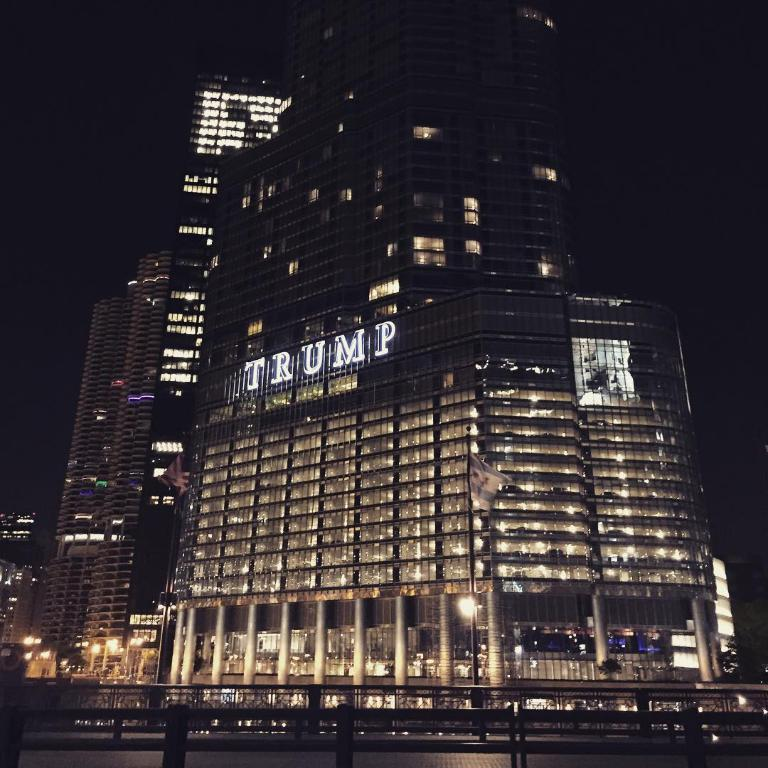<image>
Write a terse but informative summary of the picture. A building that says Trump on the side of it. 